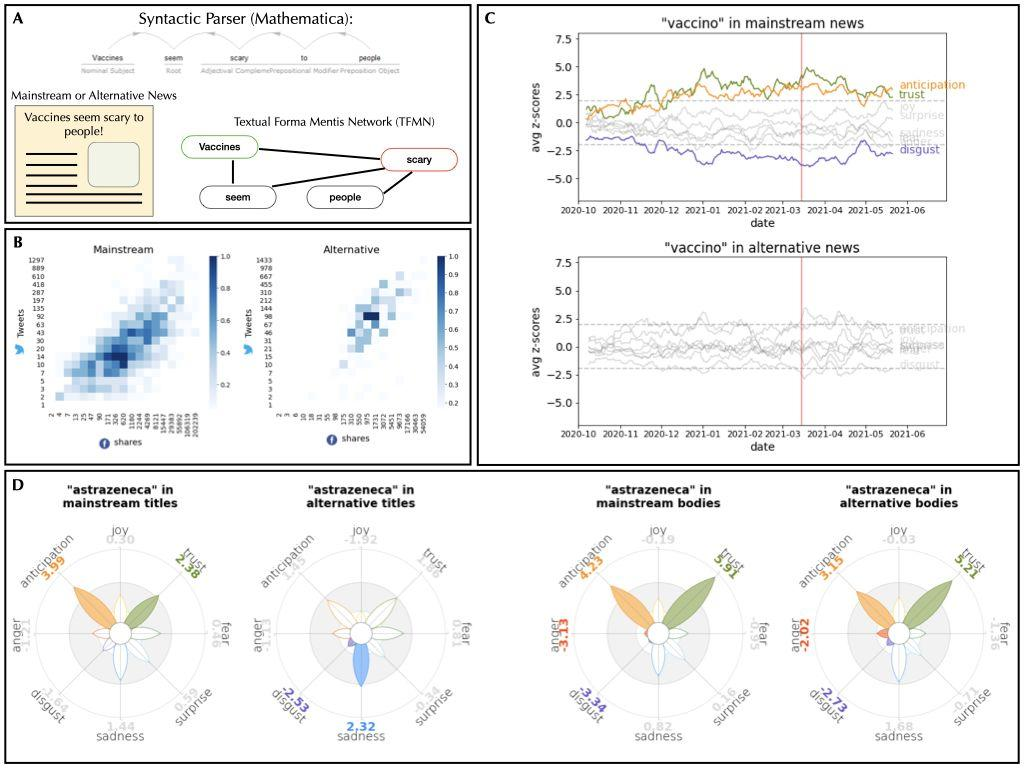What can be inferred about the distribution of the word "shares" in news articles, as shown in Figure B? A. The word "shares" is more evenly distributed in mainstream news compared to alternative news. B. The word "shares" appears exclusively in mainstream news. C. The word "shares" is predominantly found in the initial segments of articles in alternative news. D. The word "shares" has a higher frequency in alternative news than in mainstream news. ## Figure C The heat maps in Figure B show the distribution of the word "shares" in news articles, with the x-axis presumably representing the position in the article and the y-axis the frequency. The mainstream news heatmap shows a more even distribution across the article compared to the alternative news heatmap, which shows a less dense and more sporadic distribution. Therefore, the correct answer is A. 